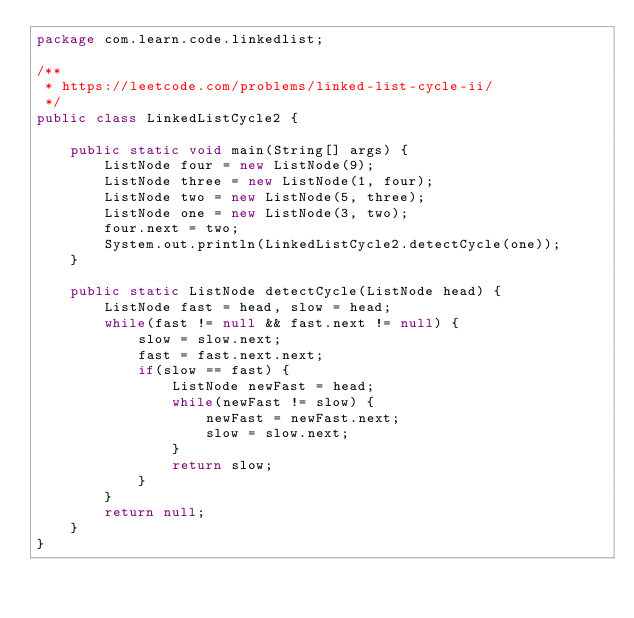Convert code to text. <code><loc_0><loc_0><loc_500><loc_500><_Java_>package com.learn.code.linkedlist;

/**
 * https://leetcode.com/problems/linked-list-cycle-ii/
 */
public class LinkedListCycle2 {

    public static void main(String[] args) {
        ListNode four = new ListNode(9);
        ListNode three = new ListNode(1, four);
        ListNode two = new ListNode(5, three);
        ListNode one = new ListNode(3, two);
        four.next = two;
        System.out.println(LinkedListCycle2.detectCycle(one));
    }

    public static ListNode detectCycle(ListNode head) {
        ListNode fast = head, slow = head;
        while(fast != null && fast.next != null) {
            slow = slow.next;
            fast = fast.next.next;
            if(slow == fast) {
                ListNode newFast = head;
                while(newFast != slow) {
                    newFast = newFast.next;
                    slow = slow.next;
                }
                return slow;
            }
        }
        return null;
    }
}
</code> 